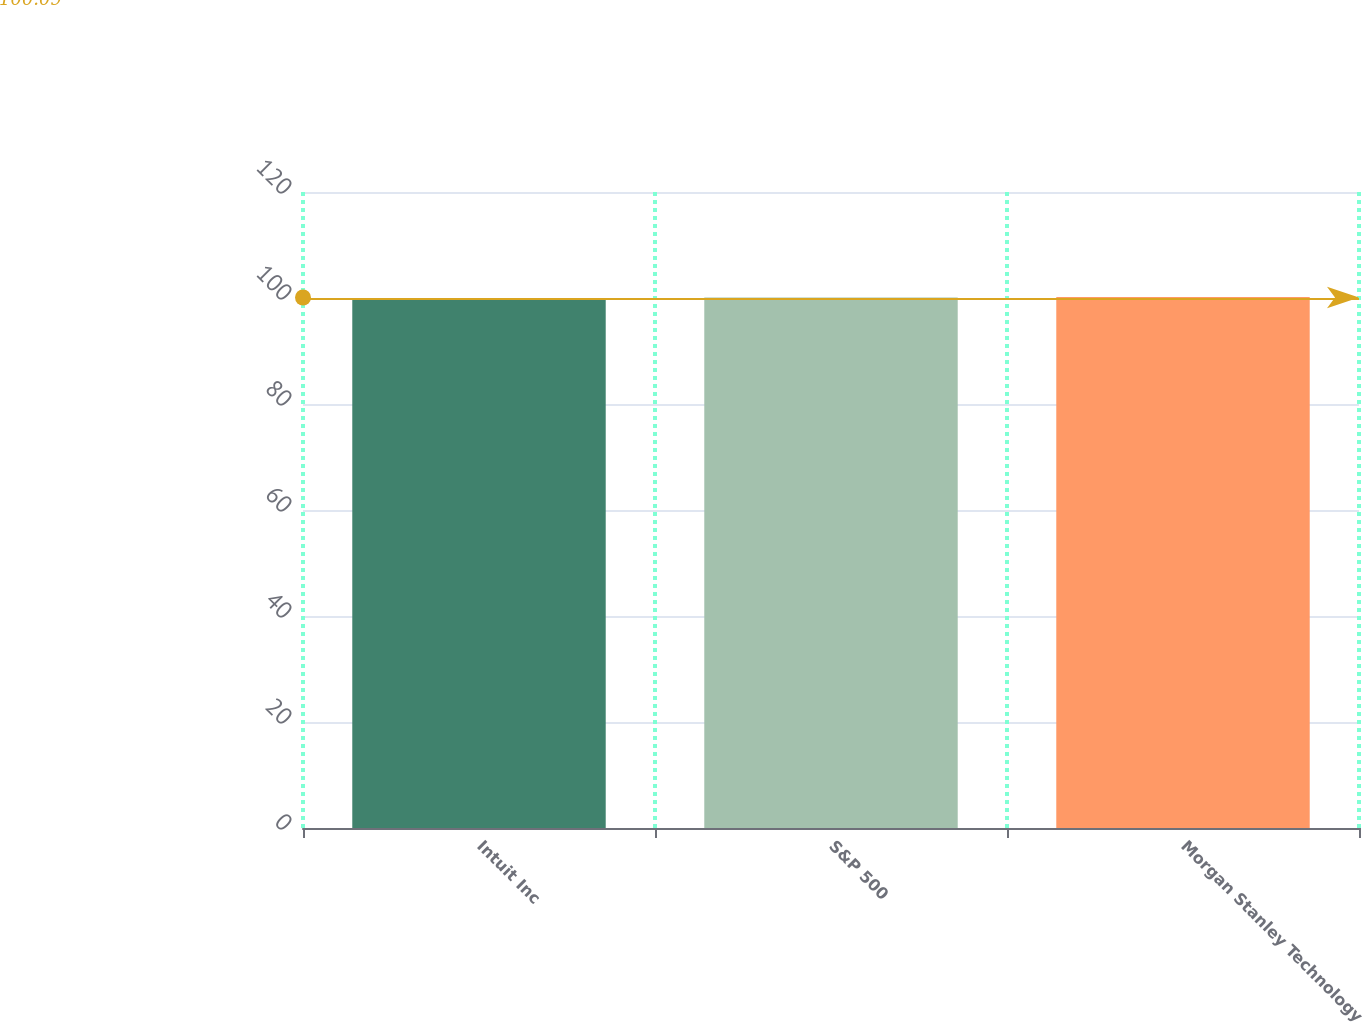Convert chart. <chart><loc_0><loc_0><loc_500><loc_500><bar_chart><fcel>Intuit Inc<fcel>S&P 500<fcel>Morgan Stanley Technology<nl><fcel>100<fcel>100.1<fcel>100.2<nl></chart> 